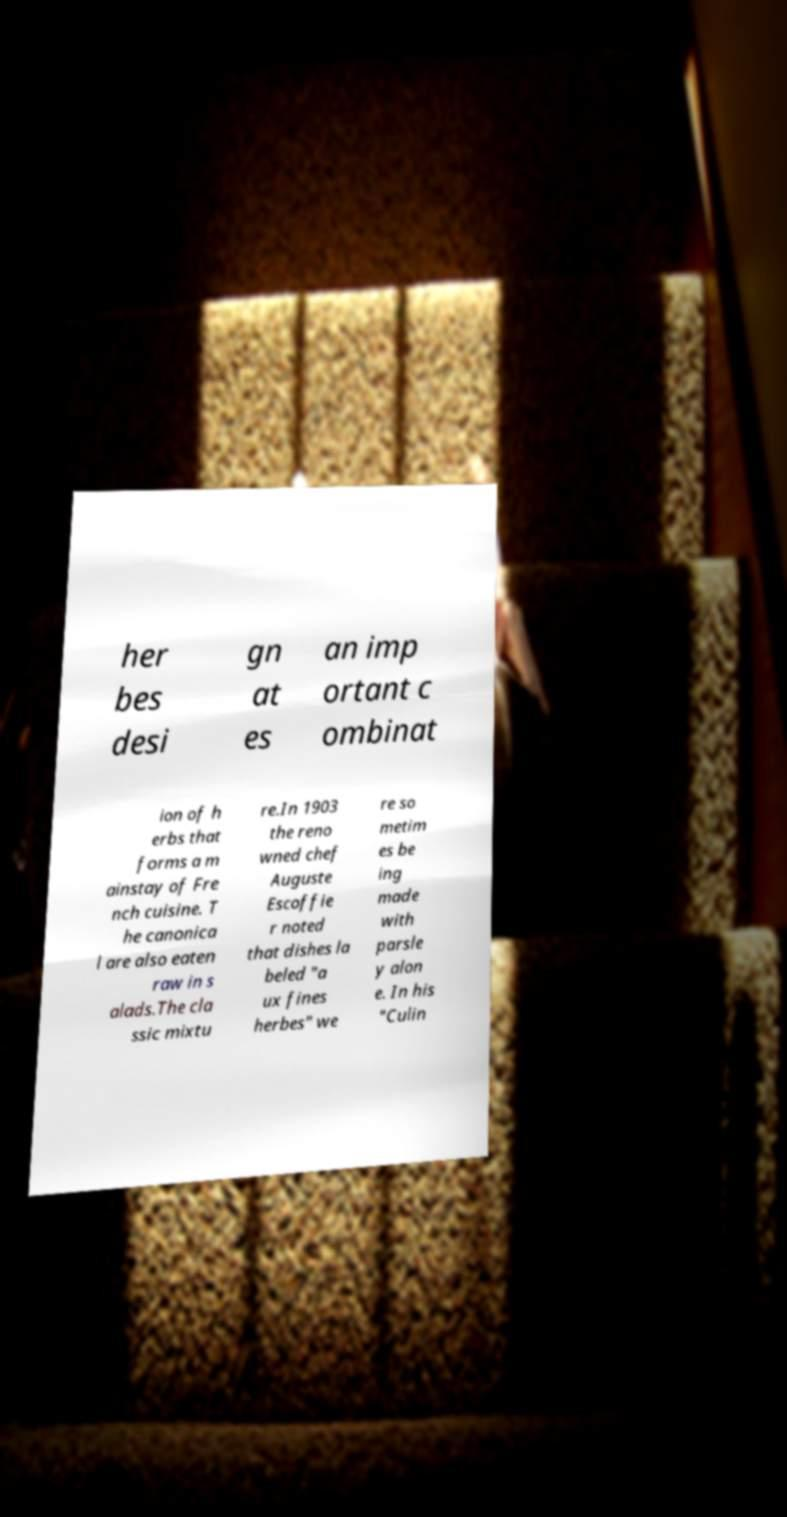Please read and relay the text visible in this image. What does it say? her bes desi gn at es an imp ortant c ombinat ion of h erbs that forms a m ainstay of Fre nch cuisine. T he canonica l are also eaten raw in s alads.The cla ssic mixtu re.In 1903 the reno wned chef Auguste Escoffie r noted that dishes la beled "a ux fines herbes" we re so metim es be ing made with parsle y alon e. In his "Culin 